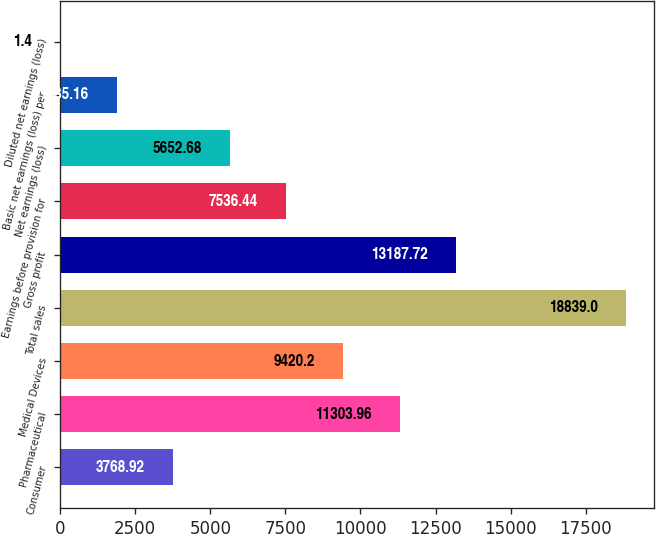Convert chart. <chart><loc_0><loc_0><loc_500><loc_500><bar_chart><fcel>Consumer<fcel>Pharmaceutical<fcel>Medical Devices<fcel>Total sales<fcel>Gross profit<fcel>Earnings before provision for<fcel>Net earnings (loss)<fcel>Basic net earnings (loss) per<fcel>Diluted net earnings (loss)<nl><fcel>3768.92<fcel>11304<fcel>9420.2<fcel>18839<fcel>13187.7<fcel>7536.44<fcel>5652.68<fcel>1885.16<fcel>1.4<nl></chart> 